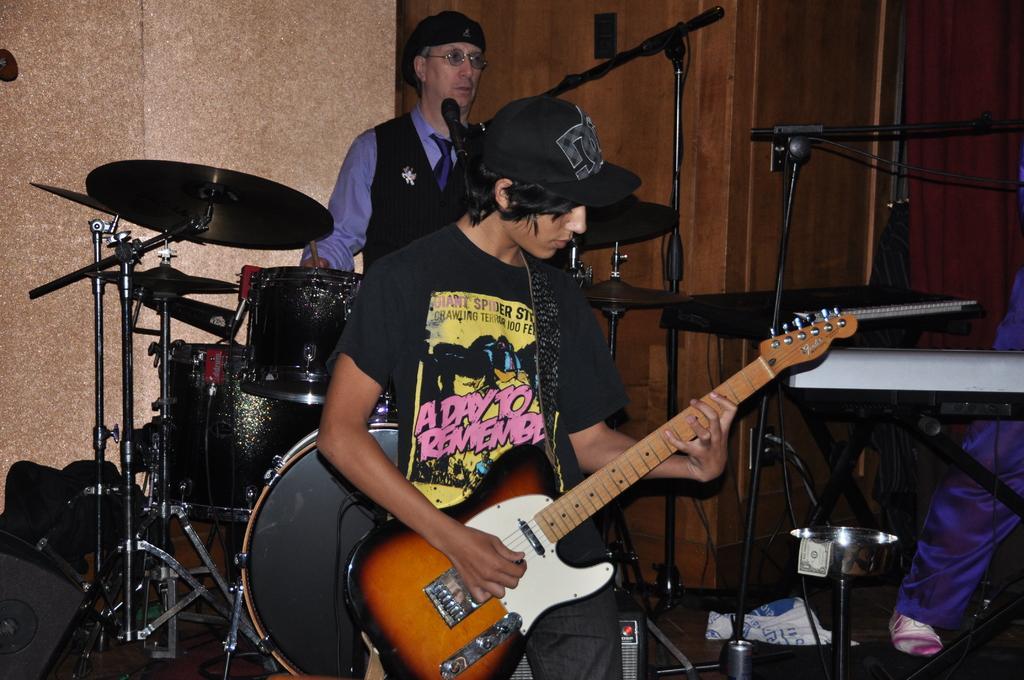Describe this image in one or two sentences. There are three persons. They are standing. They are playing a musical instruments. They are wearing a cap. We can see in background cupboard,wall and musical instruments. 